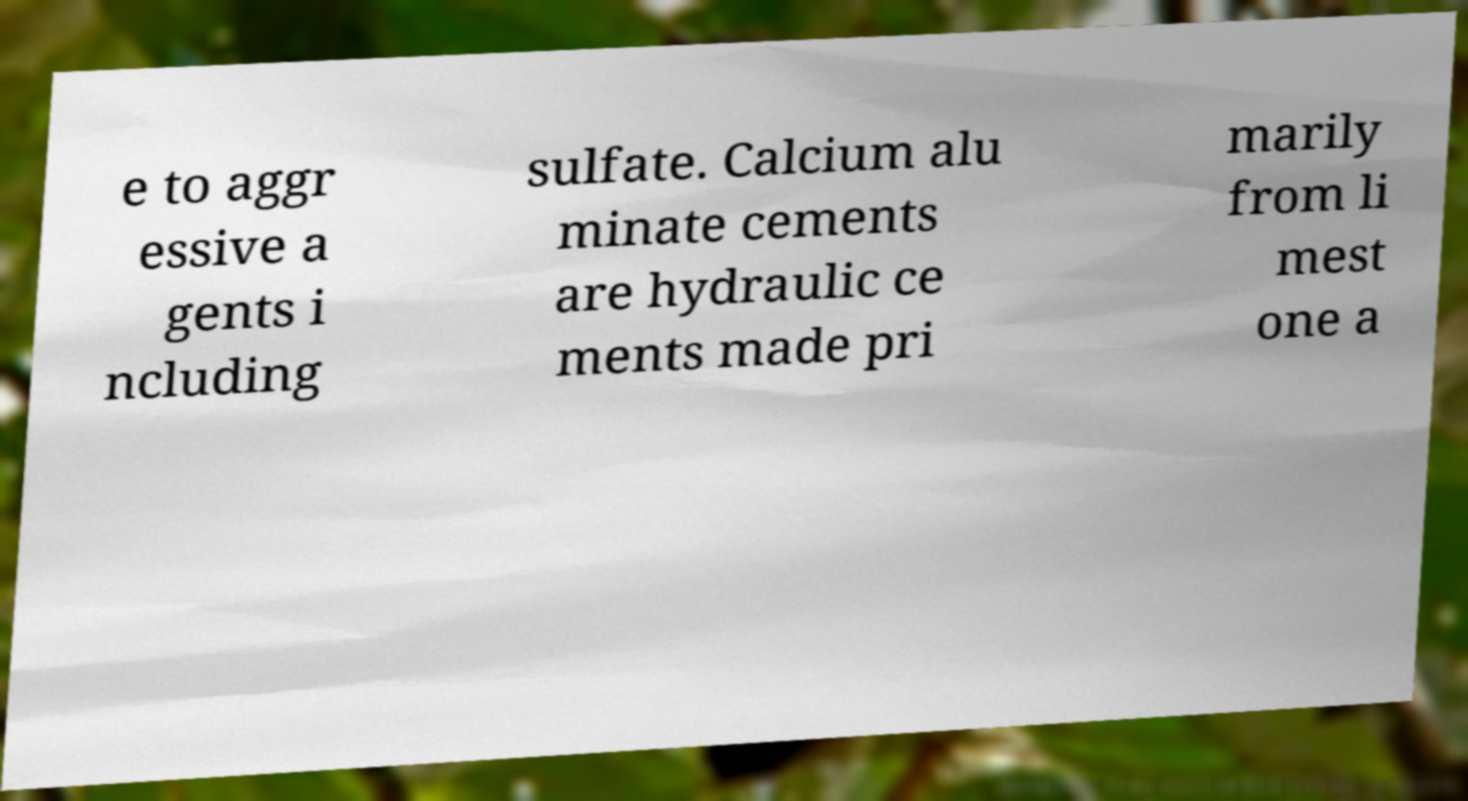Could you extract and type out the text from this image? e to aggr essive a gents i ncluding sulfate. Calcium alu minate cements are hydraulic ce ments made pri marily from li mest one a 